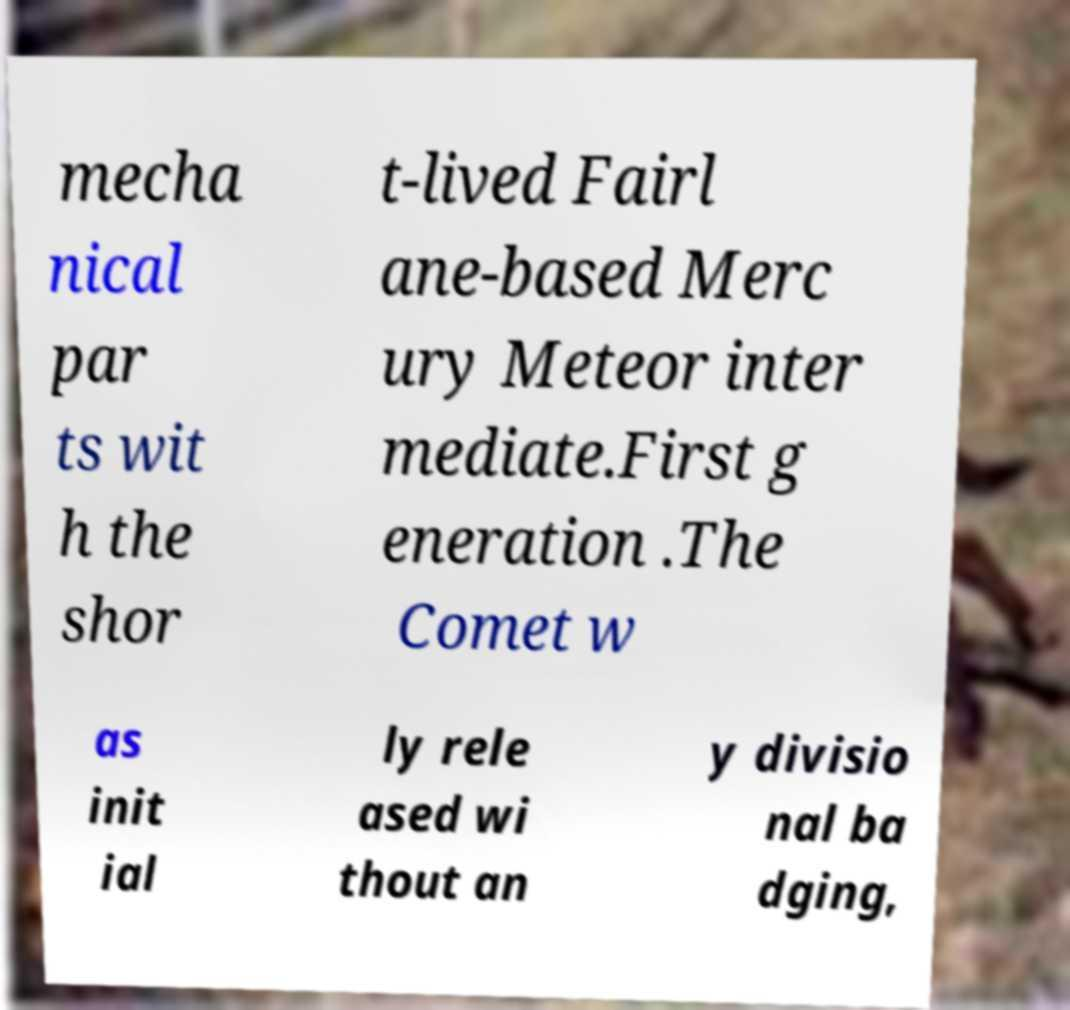For documentation purposes, I need the text within this image transcribed. Could you provide that? mecha nical par ts wit h the shor t-lived Fairl ane-based Merc ury Meteor inter mediate.First g eneration .The Comet w as init ial ly rele ased wi thout an y divisio nal ba dging, 